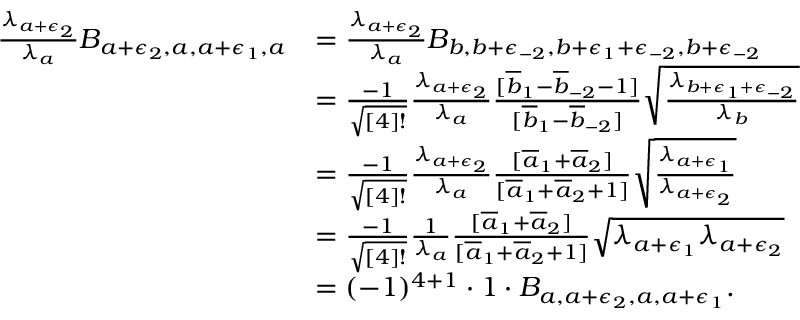Convert formula to latex. <formula><loc_0><loc_0><loc_500><loc_500>\begin{array} { r l } { \frac { \lambda _ { a + \epsilon _ { 2 } } } { \lambda _ { a } } B _ { a + \epsilon _ { 2 } , a , a + \epsilon _ { 1 } , a } } & { = \frac { \lambda _ { a + \epsilon _ { 2 } } } { \lambda _ { a } } B _ { b , b + \epsilon _ { - 2 } , b + \epsilon _ { 1 } + \epsilon _ { - 2 } , b + \epsilon _ { - 2 } } } \\ & { = \frac { - 1 } { \sqrt { [ 4 ] ! } } \frac { \lambda _ { a + \epsilon _ { 2 } } } { \lambda _ { a } } \frac { [ \overline { b } _ { 1 } - \overline { b } _ { - 2 } - 1 ] } { [ \overline { b } _ { 1 } - \overline { b } _ { - 2 } ] } \sqrt { \frac { \lambda _ { b + \epsilon _ { 1 } + \epsilon _ { - 2 } } } { \lambda _ { b } } } } \\ & { = \frac { - 1 } { \sqrt { [ 4 ] ! } } \frac { \lambda _ { a + \epsilon _ { 2 } } } { \lambda _ { a } } \frac { [ \overline { a } _ { 1 } + \overline { a } _ { 2 } ] } { [ \overline { a } _ { 1 } + \overline { a } _ { 2 } + 1 ] } \sqrt { \frac { \lambda _ { a + \epsilon _ { 1 } } } { \lambda _ { a + \epsilon _ { 2 } } } } } \\ & { = \frac { - 1 } { \sqrt { [ 4 ] ! } } \frac { 1 } { \lambda _ { a } } \frac { [ \overline { a } _ { 1 } + \overline { a } _ { 2 } ] } { [ \overline { a } _ { 1 } + \overline { a } _ { 2 } + 1 ] } \sqrt { \lambda _ { a + \epsilon _ { 1 } } \lambda _ { a + \epsilon _ { 2 } } } } \\ & { = ( - 1 ) ^ { 4 + 1 } \cdot 1 \cdot B _ { a , a + \epsilon _ { 2 } , a , a + \epsilon _ { 1 } } . } \end{array}</formula> 